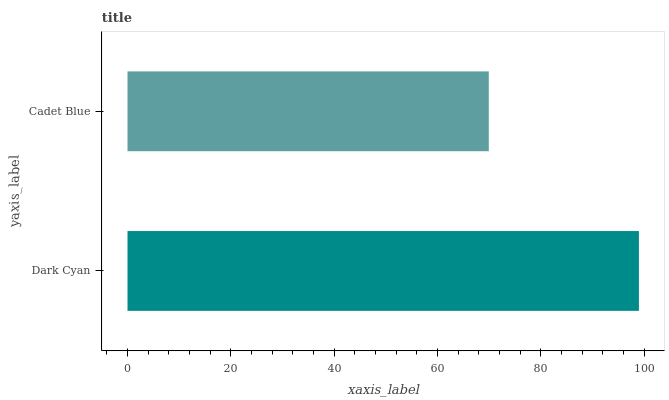Is Cadet Blue the minimum?
Answer yes or no. Yes. Is Dark Cyan the maximum?
Answer yes or no. Yes. Is Cadet Blue the maximum?
Answer yes or no. No. Is Dark Cyan greater than Cadet Blue?
Answer yes or no. Yes. Is Cadet Blue less than Dark Cyan?
Answer yes or no. Yes. Is Cadet Blue greater than Dark Cyan?
Answer yes or no. No. Is Dark Cyan less than Cadet Blue?
Answer yes or no. No. Is Dark Cyan the high median?
Answer yes or no. Yes. Is Cadet Blue the low median?
Answer yes or no. Yes. Is Cadet Blue the high median?
Answer yes or no. No. Is Dark Cyan the low median?
Answer yes or no. No. 